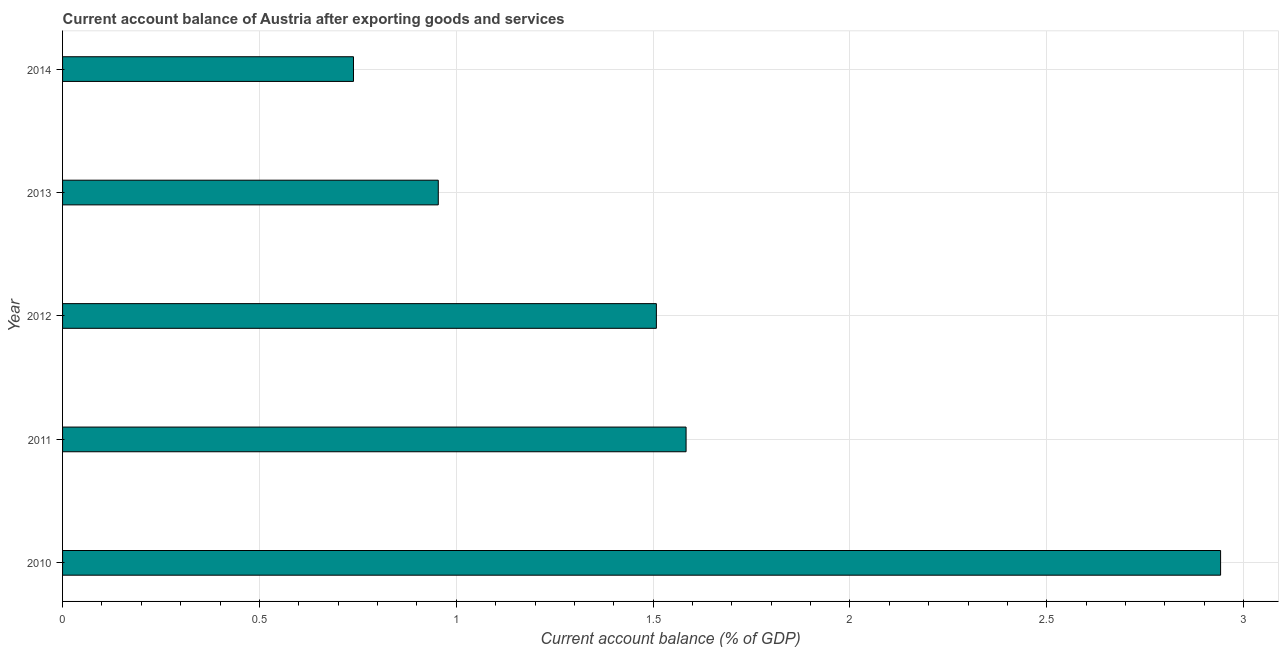Does the graph contain any zero values?
Your answer should be very brief. No. What is the title of the graph?
Give a very brief answer. Current account balance of Austria after exporting goods and services. What is the label or title of the X-axis?
Your response must be concise. Current account balance (% of GDP). What is the current account balance in 2013?
Give a very brief answer. 0.95. Across all years, what is the maximum current account balance?
Your response must be concise. 2.94. Across all years, what is the minimum current account balance?
Give a very brief answer. 0.74. In which year was the current account balance minimum?
Provide a succinct answer. 2014. What is the sum of the current account balance?
Provide a succinct answer. 7.73. What is the difference between the current account balance in 2011 and 2012?
Give a very brief answer. 0.07. What is the average current account balance per year?
Offer a terse response. 1.54. What is the median current account balance?
Make the answer very short. 1.51. What is the ratio of the current account balance in 2010 to that in 2014?
Give a very brief answer. 3.98. Is the difference between the current account balance in 2012 and 2013 greater than the difference between any two years?
Keep it short and to the point. No. What is the difference between the highest and the second highest current account balance?
Your response must be concise. 1.36. Is the sum of the current account balance in 2011 and 2012 greater than the maximum current account balance across all years?
Ensure brevity in your answer.  Yes. How many bars are there?
Provide a succinct answer. 5. Are the values on the major ticks of X-axis written in scientific E-notation?
Provide a succinct answer. No. What is the Current account balance (% of GDP) in 2010?
Offer a terse response. 2.94. What is the Current account balance (% of GDP) of 2011?
Provide a succinct answer. 1.58. What is the Current account balance (% of GDP) in 2012?
Make the answer very short. 1.51. What is the Current account balance (% of GDP) of 2013?
Offer a terse response. 0.95. What is the Current account balance (% of GDP) of 2014?
Offer a very short reply. 0.74. What is the difference between the Current account balance (% of GDP) in 2010 and 2011?
Provide a short and direct response. 1.36. What is the difference between the Current account balance (% of GDP) in 2010 and 2012?
Provide a succinct answer. 1.43. What is the difference between the Current account balance (% of GDP) in 2010 and 2013?
Make the answer very short. 1.99. What is the difference between the Current account balance (% of GDP) in 2010 and 2014?
Provide a short and direct response. 2.2. What is the difference between the Current account balance (% of GDP) in 2011 and 2012?
Ensure brevity in your answer.  0.08. What is the difference between the Current account balance (% of GDP) in 2011 and 2013?
Keep it short and to the point. 0.63. What is the difference between the Current account balance (% of GDP) in 2011 and 2014?
Give a very brief answer. 0.84. What is the difference between the Current account balance (% of GDP) in 2012 and 2013?
Provide a short and direct response. 0.55. What is the difference between the Current account balance (% of GDP) in 2012 and 2014?
Keep it short and to the point. 0.77. What is the difference between the Current account balance (% of GDP) in 2013 and 2014?
Provide a succinct answer. 0.22. What is the ratio of the Current account balance (% of GDP) in 2010 to that in 2011?
Give a very brief answer. 1.86. What is the ratio of the Current account balance (% of GDP) in 2010 to that in 2012?
Ensure brevity in your answer.  1.95. What is the ratio of the Current account balance (% of GDP) in 2010 to that in 2013?
Your answer should be very brief. 3.08. What is the ratio of the Current account balance (% of GDP) in 2010 to that in 2014?
Make the answer very short. 3.98. What is the ratio of the Current account balance (% of GDP) in 2011 to that in 2013?
Offer a very short reply. 1.66. What is the ratio of the Current account balance (% of GDP) in 2011 to that in 2014?
Keep it short and to the point. 2.14. What is the ratio of the Current account balance (% of GDP) in 2012 to that in 2013?
Provide a short and direct response. 1.58. What is the ratio of the Current account balance (% of GDP) in 2012 to that in 2014?
Your response must be concise. 2.04. What is the ratio of the Current account balance (% of GDP) in 2013 to that in 2014?
Your answer should be compact. 1.29. 